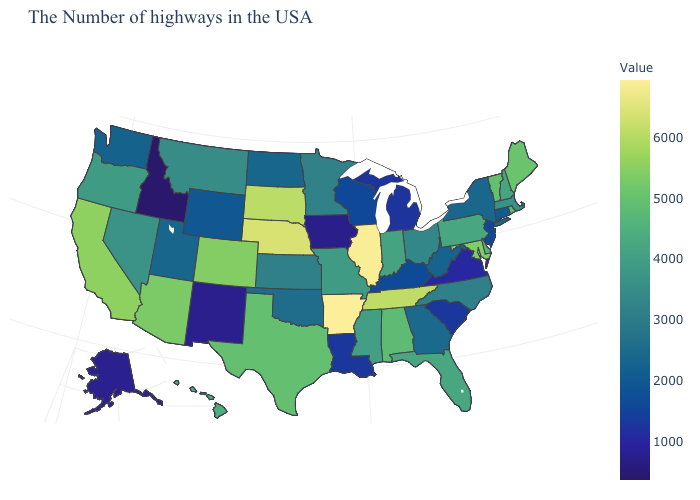Is the legend a continuous bar?
Keep it brief. Yes. Does the map have missing data?
Give a very brief answer. No. Which states hav the highest value in the MidWest?
Write a very short answer. Illinois. Among the states that border Kentucky , which have the highest value?
Give a very brief answer. Illinois. Among the states that border Maryland , does Delaware have the highest value?
Short answer required. Yes. 